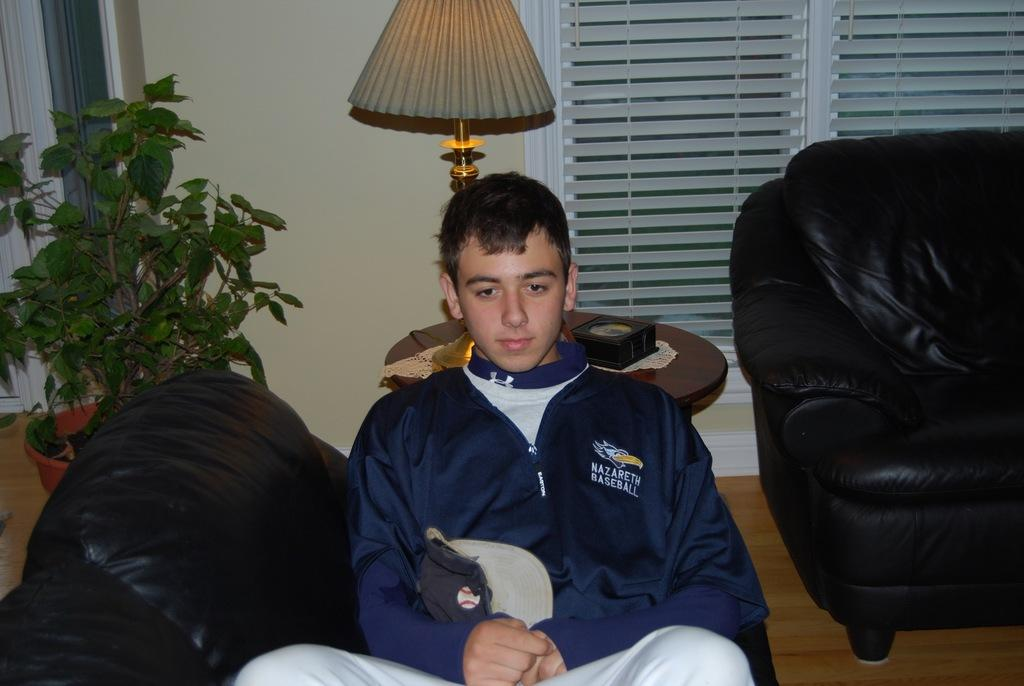What is the man in the image doing? The man is seated on a chair in the image. What objects are on the table in the image? There is a plant and a lamp on a table in the image. What type of window treatment is present in the image? There are blinds on a window in the image. What type of furniture is on the side in the image? There is a sofa on the side in the image. Can you see any jellyfish swimming in the basin in the image? There is no basin or jellyfish present in the image. 